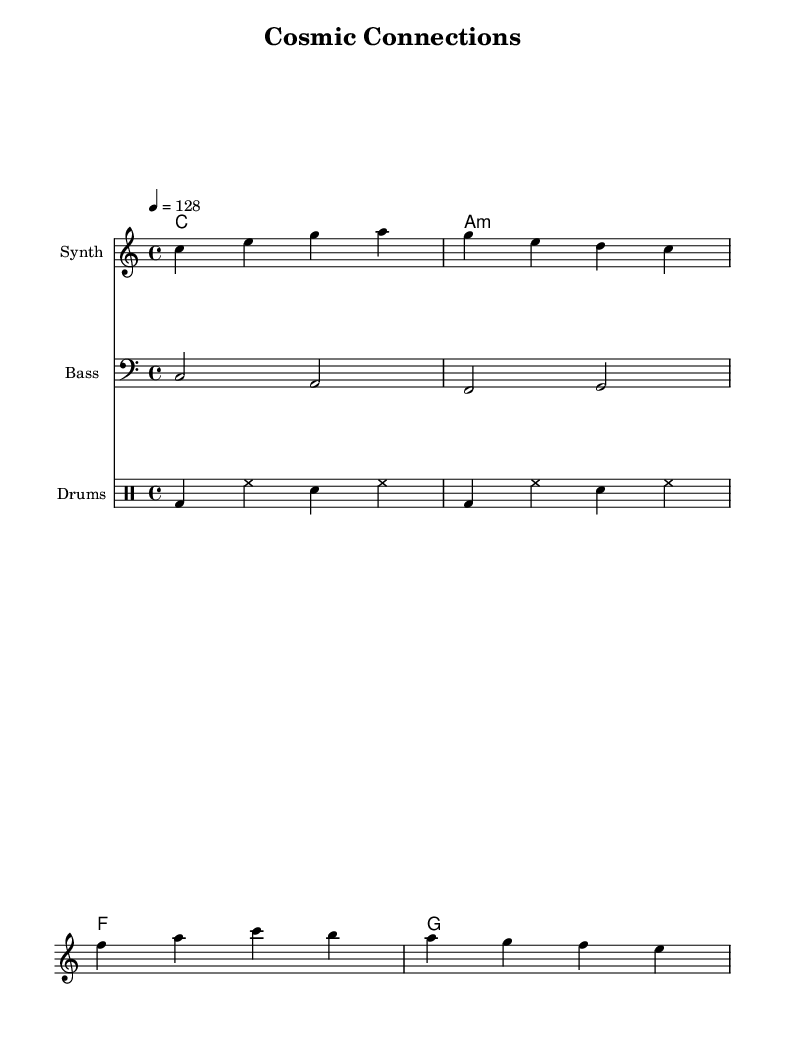What is the key signature of this music? The key signature is C major, which has no sharps or flats.
Answer: C major What is the time signature of this piece? The time signature is shown at the beginning of the score; it is 4/4, which means there are four beats in each measure.
Answer: 4/4 What is the tempo marking for this composition? The tempo marking in the score indicates the speed; it is set at 128 beats per minute.
Answer: 128 How many measures are present in the melody section? By counting each group of notes separated by vertical lines in the melody staff, there are four measures.
Answer: 4 What is the first lyric line of the song? The first lyric line can be found directly under the melody staff at the start, which reads “Gazing up at starry skies.”
Answer: Gazing up at starry skies What kind of chords are used in the harmony section? The chord mode shows that the piece uses major and minor chords, specifically C major, A minor, F major, and G major.
Answer: Major and minor chords What instruments are featured in this score? By examining the score, there are three distinct staves indicating a Synth, Bass, and Drums, which represent the instruments used in this piece.
Answer: Synth, Bass, Drums 